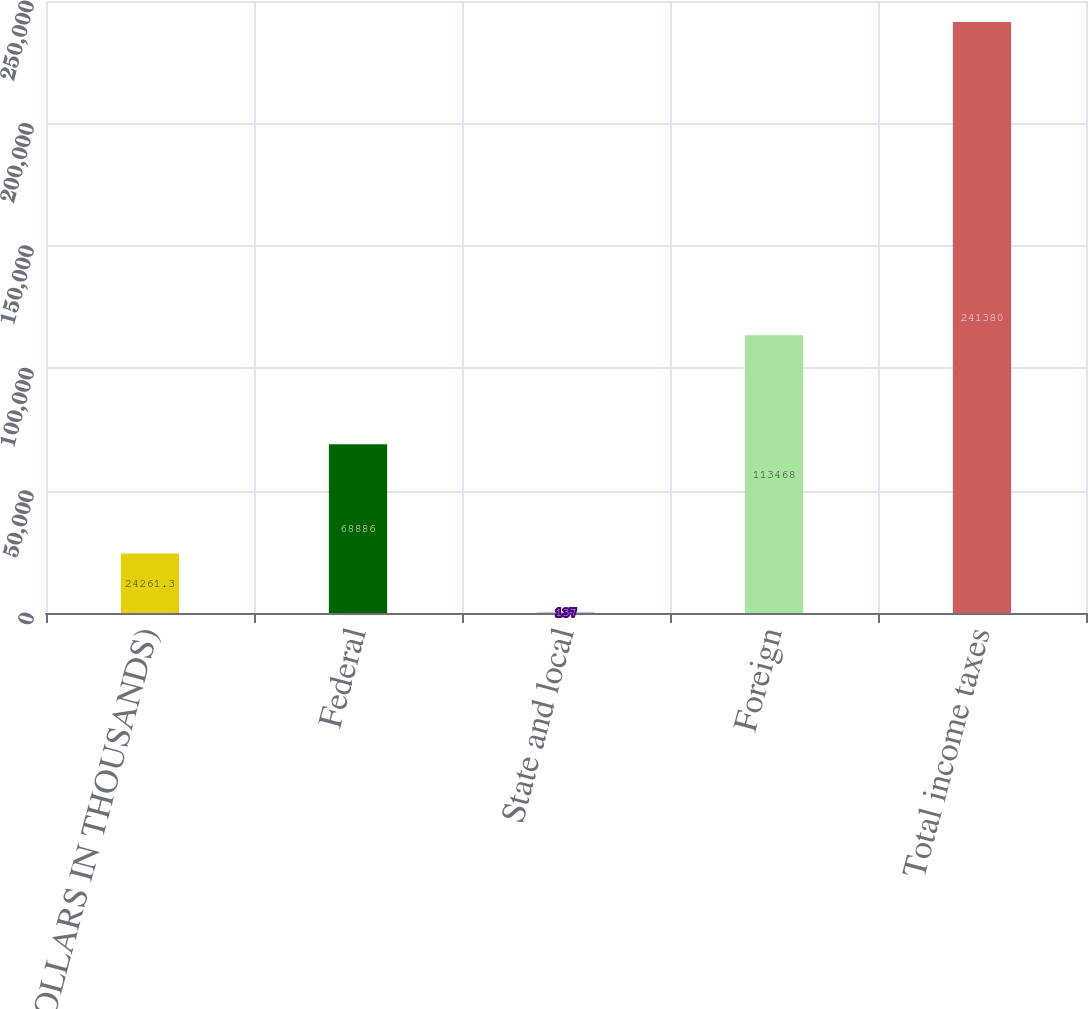Convert chart. <chart><loc_0><loc_0><loc_500><loc_500><bar_chart><fcel>(DOLLARS IN THOUSANDS)<fcel>Federal<fcel>State and local<fcel>Foreign<fcel>Total income taxes<nl><fcel>24261.3<fcel>68886<fcel>137<fcel>113468<fcel>241380<nl></chart> 